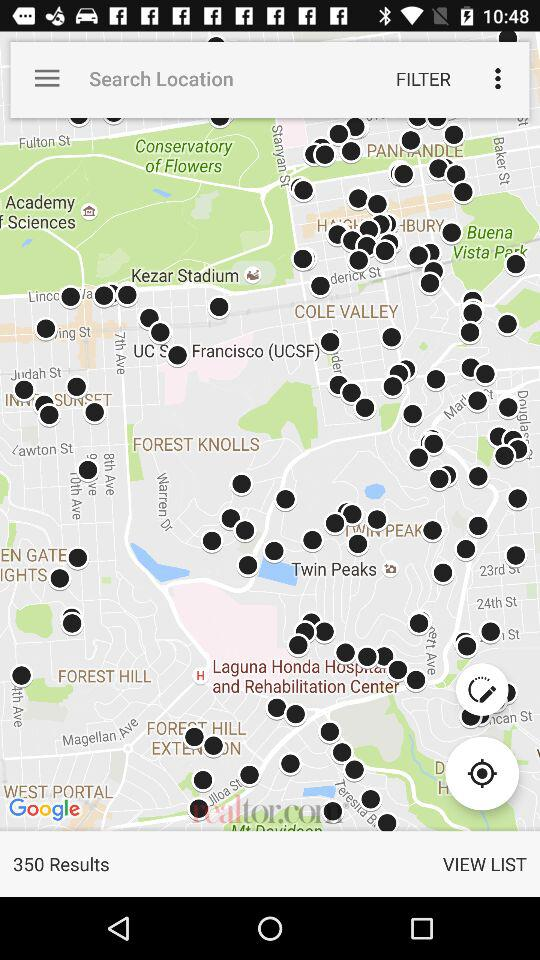How far away is the location?
When the provided information is insufficient, respond with <no answer>. <no answer> 